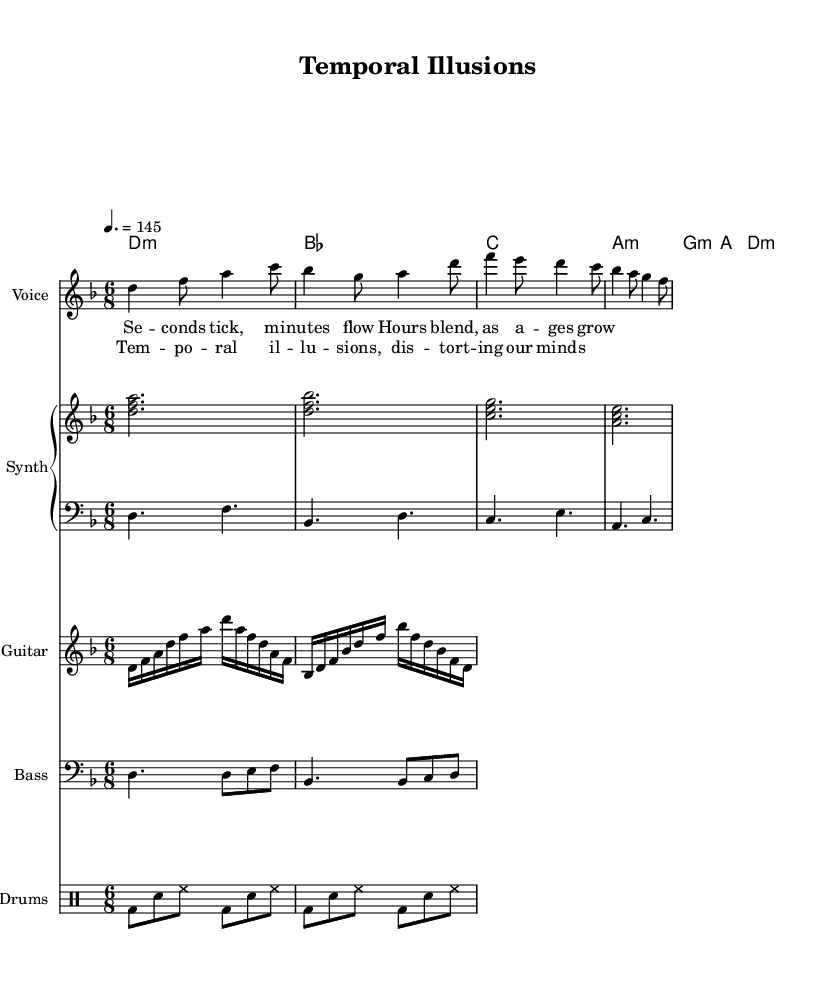What is the key signature of this music? The key signature is indicated at the beginning of the staff, showing two flats. This means the piece is in D minor, which is associated with one flat (B) in addition to the key itself.
Answer: D minor What is the time signature of this music? The time signature appears at the beginning of the sheet music, represented by the "6/8" notation. This indicates there are six eighth notes per measure.
Answer: 6/8 What is the tempo marking? The tempo marking is specified in the score using "4. = 145," which tells the performer to play at a speed of 145 beats per minute, aligning with the quarter note.
Answer: 145 Which instrument is primarily featured for the melody? The melody is assigned to the "Voice" staff, which indicates that it is meant to be sung or performed vocally in this instance.
Answer: Voice How many chords are used in the harmonic progression? By analyzing the chord mode section, I count six distinct chord symbols being played, namely D minor, B flat major, C major, A minor, G minor, and D minor again.
Answer: Six What is the overall mood suggested by the combination of the music's key and tempo? The D minor key typically conveys a somber and introspective mood, and when combined with a moderately fast tempo like 145, it can suggest a sense of urgency or tension as it portrays a conflict with the philosophical theme of time.
Answer: Somber urgency What lyrical theme is addressed in the chorus? The lyrics of the chorus mention "Temporal illusions, distorting our minds," indicating a philosophical exploration of how time affects human perception and understanding.
Answer: Temporal illusions 